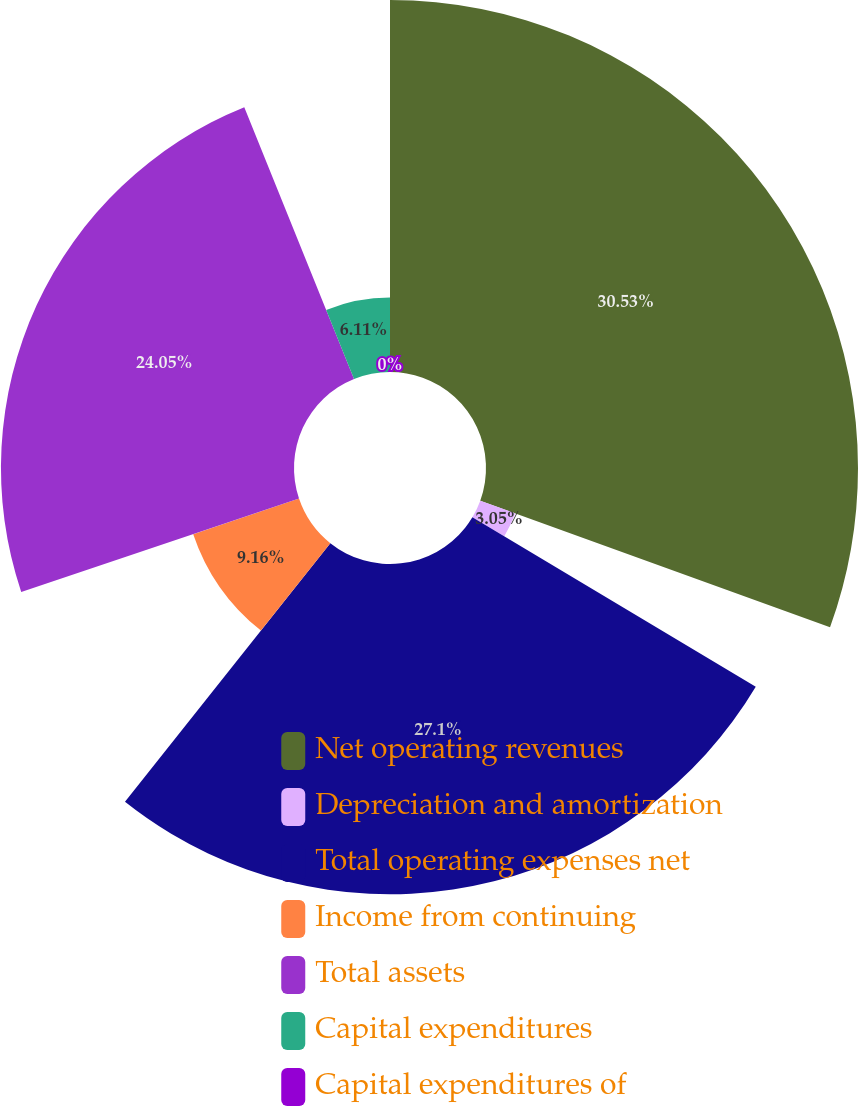<chart> <loc_0><loc_0><loc_500><loc_500><pie_chart><fcel>Net operating revenues<fcel>Depreciation and amortization<fcel>Total operating expenses net<fcel>Income from continuing<fcel>Total assets<fcel>Capital expenditures<fcel>Capital expenditures of<nl><fcel>30.53%<fcel>3.05%<fcel>27.1%<fcel>9.16%<fcel>24.05%<fcel>6.11%<fcel>0.0%<nl></chart> 